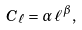<formula> <loc_0><loc_0><loc_500><loc_500>C _ { \ell } = \alpha \, \ell ^ { \beta } \, ,</formula> 